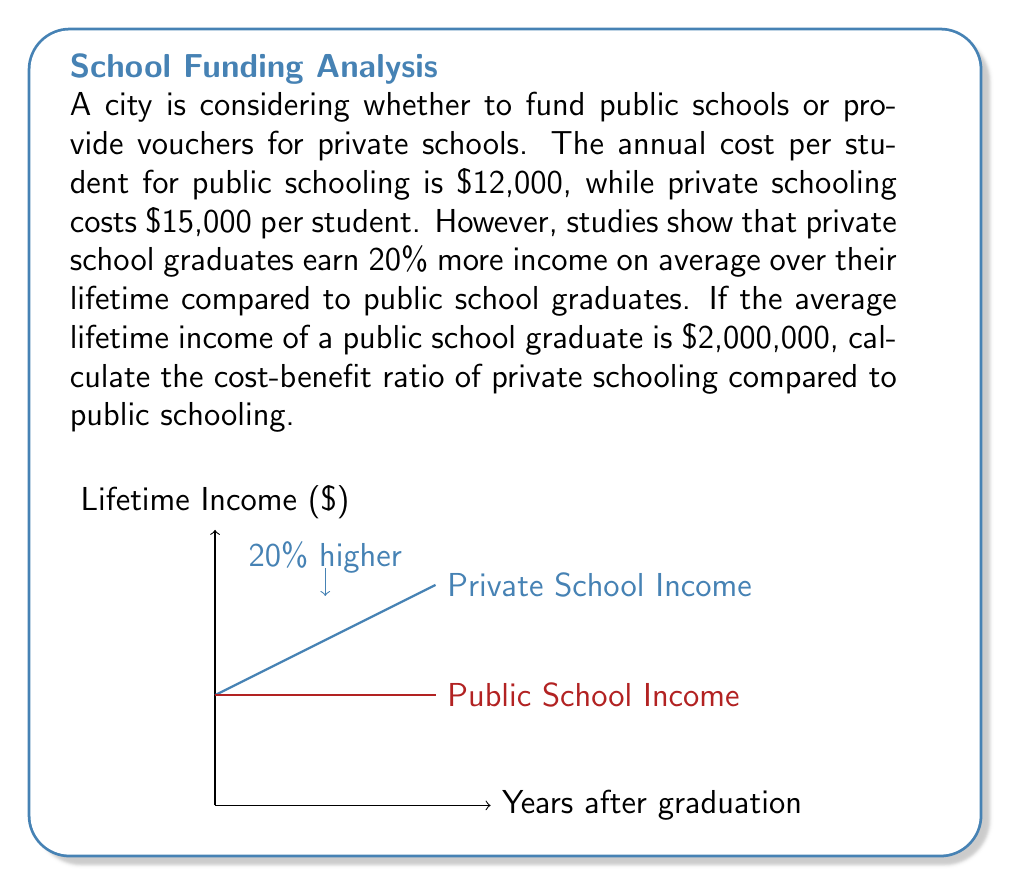Help me with this question. Let's approach this step-by-step:

1) First, calculate the lifetime income of a private school graduate:
   $2,000,000 * 1.20 = $2,400,000

2) Calculate the difference in lifetime income:
   $2,400,000 - $2,000,000 = $400,000

3) Calculate the difference in schooling cost:
   $15,000 - $12,000 = $3,000 per year
   Assuming 12 years of schooling: $3,000 * 12 = $36,000

4) The cost-benefit ratio is calculated as:
   $\text{Ratio} = \frac{\text{Benefit}}{\text{Cost}} = \frac{\text{Difference in Income}}{\text{Difference in Cost}}$

   $\text{Ratio} = \frac{$400,000}{$36,000} = \frac{400}{36} \approx 11.11$

This means that for every additional dollar spent on private schooling, there's a benefit of $11.11 in lifetime income.
Answer: 11.11 